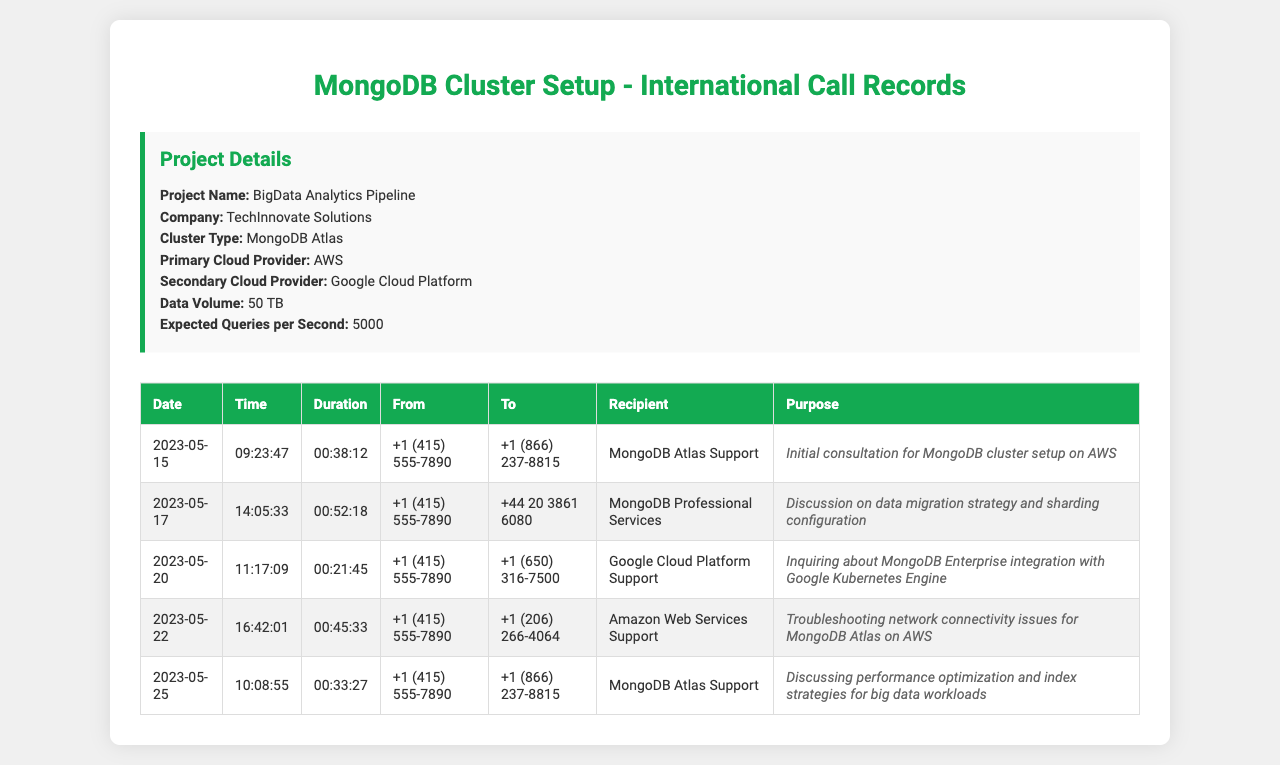What is the project name? The project name is listed in the "Project Details" section of the document.
Answer: BigData Analytics Pipeline Who is the primary cloud provider? The primary cloud provider is mentioned in the "Project Details" section.
Answer: AWS What was the date of the call to MongoDB Atlas Support? The date of the call to MongoDB Atlas Support can be found in the call records table.
Answer: 2023-05-15 How long was the discussion with MongoDB Professional Services on data migration strategy? The duration is provided in the call records table for the specific call.
Answer: 00:52:18 What was the purpose of the call on 2023-05-20? The purpose of the call is described in the call records table corresponding to that date.
Answer: Inquiring about MongoDB Enterprise integration with Google Kubernetes Engine Which support team was called on 2023-05-22? The recipient support team is listed next to the call details in the table.
Answer: Amazon Web Services Support What is the expected queries per second? The expected queries per second is outlined in the "Project Details" section.
Answer: 5000 Which call was about performance optimization? The details regarding calls about performance optimization are provided in the call records table.
Answer: 2023-05-25 What is the duration of the initial consultation call? The call duration is mentioned in the call records table for the specific call.
Answer: 00:38:12 